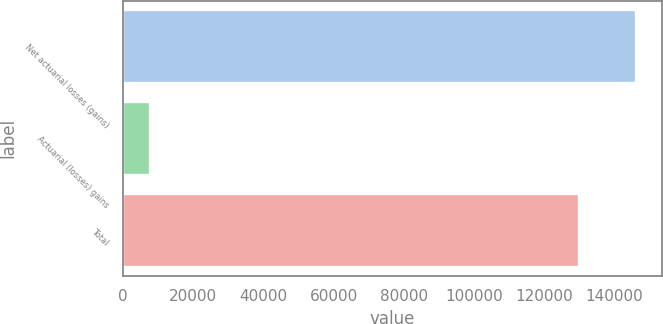Convert chart to OTSL. <chart><loc_0><loc_0><loc_500><loc_500><bar_chart><fcel>Net actuarial losses (gains)<fcel>Actuarial (losses) gains<fcel>Total<nl><fcel>146270<fcel>7672<fcel>129967<nl></chart> 